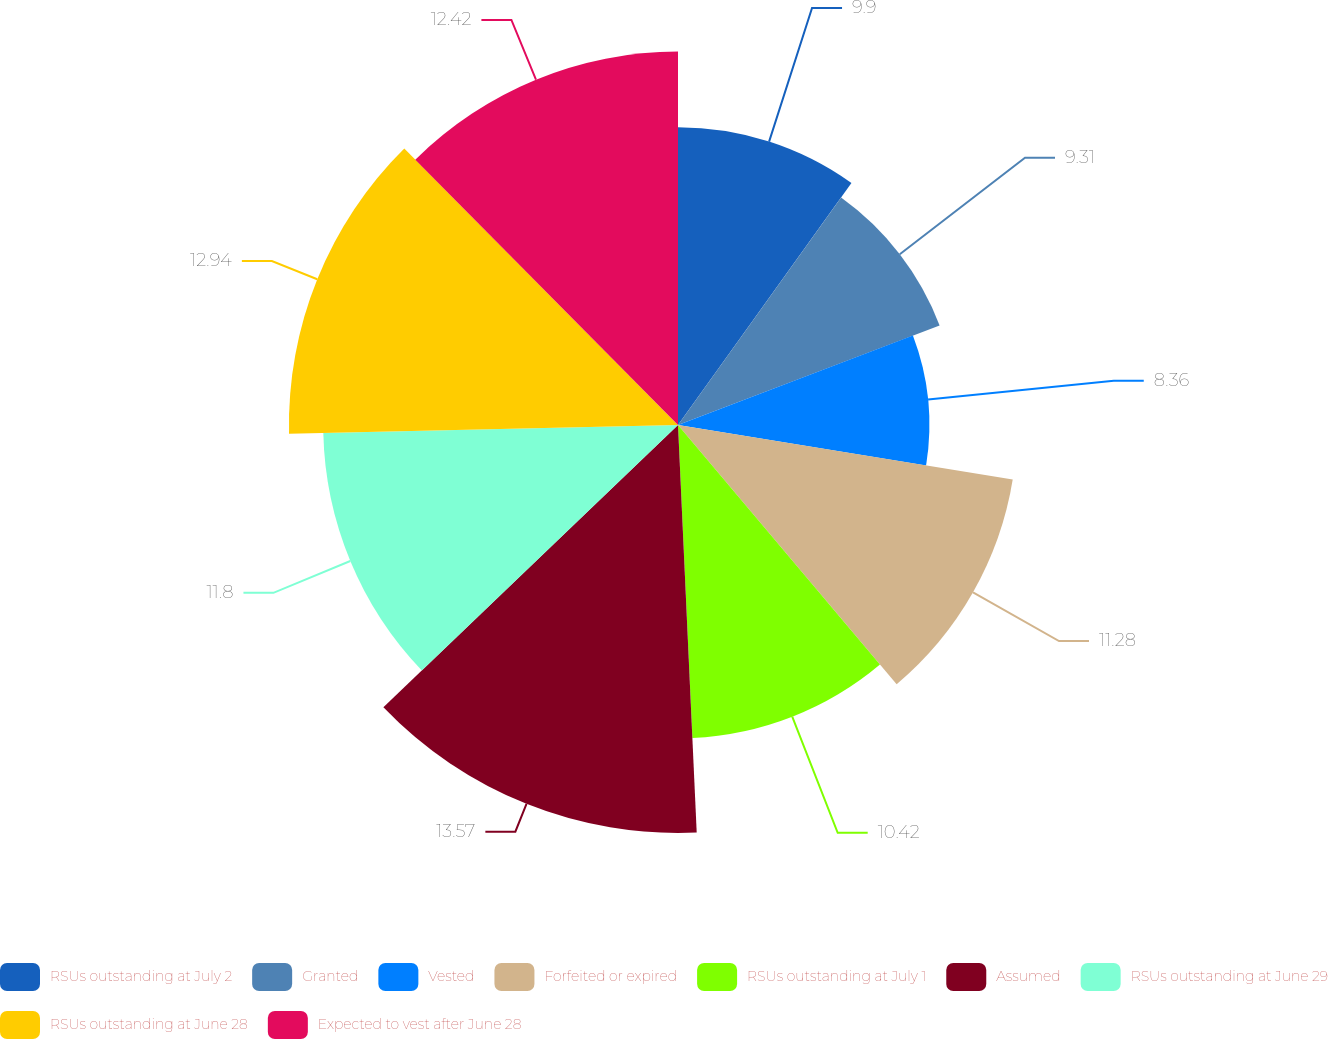Convert chart. <chart><loc_0><loc_0><loc_500><loc_500><pie_chart><fcel>RSUs outstanding at July 2<fcel>Granted<fcel>Vested<fcel>Forfeited or expired<fcel>RSUs outstanding at July 1<fcel>Assumed<fcel>RSUs outstanding at June 29<fcel>RSUs outstanding at June 28<fcel>Expected to vest after June 28<nl><fcel>9.9%<fcel>9.31%<fcel>8.36%<fcel>11.28%<fcel>10.42%<fcel>13.57%<fcel>11.8%<fcel>12.94%<fcel>12.42%<nl></chart> 